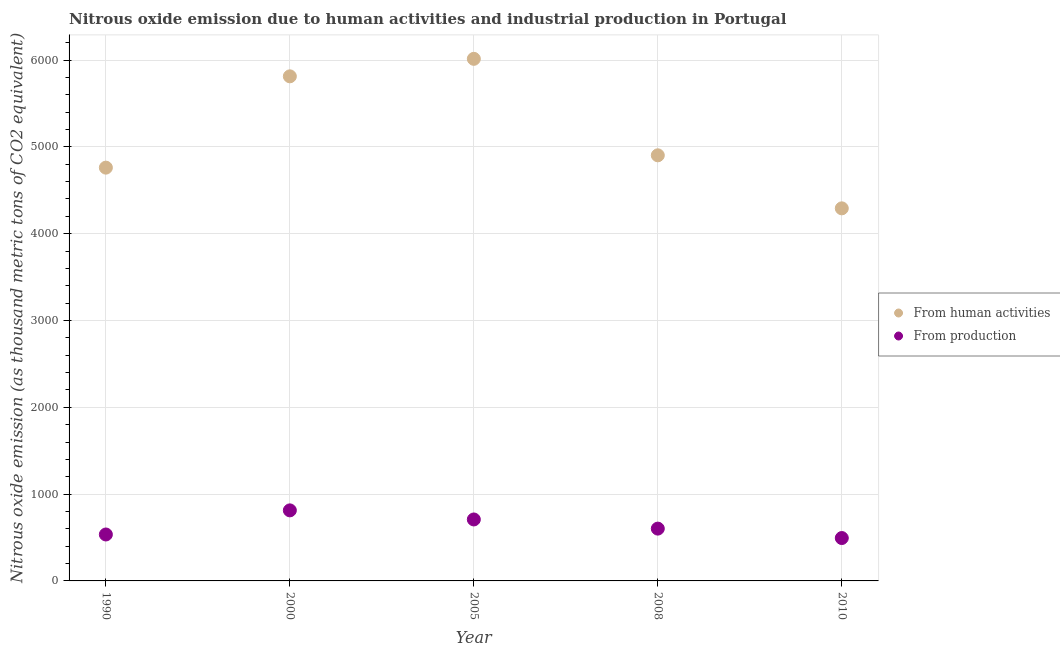How many different coloured dotlines are there?
Provide a succinct answer. 2. Is the number of dotlines equal to the number of legend labels?
Offer a terse response. Yes. What is the amount of emissions from human activities in 2008?
Offer a terse response. 4902.8. Across all years, what is the maximum amount of emissions generated from industries?
Your answer should be very brief. 812.7. Across all years, what is the minimum amount of emissions from human activities?
Offer a terse response. 4291.9. In which year was the amount of emissions from human activities minimum?
Keep it short and to the point. 2010. What is the total amount of emissions from human activities in the graph?
Your answer should be very brief. 2.58e+04. What is the difference between the amount of emissions generated from industries in 2000 and that in 2010?
Keep it short and to the point. 318.7. What is the difference between the amount of emissions from human activities in 2010 and the amount of emissions generated from industries in 2008?
Offer a terse response. 3689.4. What is the average amount of emissions from human activities per year?
Make the answer very short. 5156.46. In the year 2005, what is the difference between the amount of emissions from human activities and amount of emissions generated from industries?
Your answer should be compact. 5306.2. In how many years, is the amount of emissions from human activities greater than 5400 thousand metric tons?
Your answer should be very brief. 2. What is the ratio of the amount of emissions generated from industries in 1990 to that in 2005?
Provide a short and direct response. 0.76. Is the amount of emissions from human activities in 2005 less than that in 2010?
Provide a short and direct response. No. What is the difference between the highest and the second highest amount of emissions generated from industries?
Offer a very short reply. 104.7. What is the difference between the highest and the lowest amount of emissions generated from industries?
Keep it short and to the point. 318.7. Does the amount of emissions from human activities monotonically increase over the years?
Give a very brief answer. No. What is the difference between two consecutive major ticks on the Y-axis?
Your answer should be very brief. 1000. Are the values on the major ticks of Y-axis written in scientific E-notation?
Keep it short and to the point. No. Does the graph contain grids?
Your response must be concise. Yes. How many legend labels are there?
Ensure brevity in your answer.  2. What is the title of the graph?
Provide a short and direct response. Nitrous oxide emission due to human activities and industrial production in Portugal. Does "Rural Population" appear as one of the legend labels in the graph?
Your answer should be compact. No. What is the label or title of the Y-axis?
Offer a terse response. Nitrous oxide emission (as thousand metric tons of CO2 equivalent). What is the Nitrous oxide emission (as thousand metric tons of CO2 equivalent) in From human activities in 1990?
Keep it short and to the point. 4760.8. What is the Nitrous oxide emission (as thousand metric tons of CO2 equivalent) of From production in 1990?
Ensure brevity in your answer.  534.9. What is the Nitrous oxide emission (as thousand metric tons of CO2 equivalent) in From human activities in 2000?
Make the answer very short. 5812.6. What is the Nitrous oxide emission (as thousand metric tons of CO2 equivalent) of From production in 2000?
Give a very brief answer. 812.7. What is the Nitrous oxide emission (as thousand metric tons of CO2 equivalent) of From human activities in 2005?
Your response must be concise. 6014.2. What is the Nitrous oxide emission (as thousand metric tons of CO2 equivalent) of From production in 2005?
Your response must be concise. 708. What is the Nitrous oxide emission (as thousand metric tons of CO2 equivalent) in From human activities in 2008?
Your response must be concise. 4902.8. What is the Nitrous oxide emission (as thousand metric tons of CO2 equivalent) of From production in 2008?
Provide a succinct answer. 602.5. What is the Nitrous oxide emission (as thousand metric tons of CO2 equivalent) in From human activities in 2010?
Ensure brevity in your answer.  4291.9. What is the Nitrous oxide emission (as thousand metric tons of CO2 equivalent) of From production in 2010?
Offer a terse response. 494. Across all years, what is the maximum Nitrous oxide emission (as thousand metric tons of CO2 equivalent) of From human activities?
Your response must be concise. 6014.2. Across all years, what is the maximum Nitrous oxide emission (as thousand metric tons of CO2 equivalent) in From production?
Offer a very short reply. 812.7. Across all years, what is the minimum Nitrous oxide emission (as thousand metric tons of CO2 equivalent) in From human activities?
Provide a short and direct response. 4291.9. Across all years, what is the minimum Nitrous oxide emission (as thousand metric tons of CO2 equivalent) of From production?
Your answer should be compact. 494. What is the total Nitrous oxide emission (as thousand metric tons of CO2 equivalent) in From human activities in the graph?
Keep it short and to the point. 2.58e+04. What is the total Nitrous oxide emission (as thousand metric tons of CO2 equivalent) in From production in the graph?
Make the answer very short. 3152.1. What is the difference between the Nitrous oxide emission (as thousand metric tons of CO2 equivalent) of From human activities in 1990 and that in 2000?
Your answer should be compact. -1051.8. What is the difference between the Nitrous oxide emission (as thousand metric tons of CO2 equivalent) of From production in 1990 and that in 2000?
Provide a short and direct response. -277.8. What is the difference between the Nitrous oxide emission (as thousand metric tons of CO2 equivalent) of From human activities in 1990 and that in 2005?
Your answer should be compact. -1253.4. What is the difference between the Nitrous oxide emission (as thousand metric tons of CO2 equivalent) of From production in 1990 and that in 2005?
Keep it short and to the point. -173.1. What is the difference between the Nitrous oxide emission (as thousand metric tons of CO2 equivalent) of From human activities in 1990 and that in 2008?
Make the answer very short. -142. What is the difference between the Nitrous oxide emission (as thousand metric tons of CO2 equivalent) in From production in 1990 and that in 2008?
Provide a short and direct response. -67.6. What is the difference between the Nitrous oxide emission (as thousand metric tons of CO2 equivalent) of From human activities in 1990 and that in 2010?
Provide a short and direct response. 468.9. What is the difference between the Nitrous oxide emission (as thousand metric tons of CO2 equivalent) of From production in 1990 and that in 2010?
Offer a terse response. 40.9. What is the difference between the Nitrous oxide emission (as thousand metric tons of CO2 equivalent) of From human activities in 2000 and that in 2005?
Give a very brief answer. -201.6. What is the difference between the Nitrous oxide emission (as thousand metric tons of CO2 equivalent) of From production in 2000 and that in 2005?
Make the answer very short. 104.7. What is the difference between the Nitrous oxide emission (as thousand metric tons of CO2 equivalent) in From human activities in 2000 and that in 2008?
Your answer should be compact. 909.8. What is the difference between the Nitrous oxide emission (as thousand metric tons of CO2 equivalent) in From production in 2000 and that in 2008?
Ensure brevity in your answer.  210.2. What is the difference between the Nitrous oxide emission (as thousand metric tons of CO2 equivalent) of From human activities in 2000 and that in 2010?
Offer a terse response. 1520.7. What is the difference between the Nitrous oxide emission (as thousand metric tons of CO2 equivalent) in From production in 2000 and that in 2010?
Offer a terse response. 318.7. What is the difference between the Nitrous oxide emission (as thousand metric tons of CO2 equivalent) in From human activities in 2005 and that in 2008?
Ensure brevity in your answer.  1111.4. What is the difference between the Nitrous oxide emission (as thousand metric tons of CO2 equivalent) in From production in 2005 and that in 2008?
Your response must be concise. 105.5. What is the difference between the Nitrous oxide emission (as thousand metric tons of CO2 equivalent) of From human activities in 2005 and that in 2010?
Offer a very short reply. 1722.3. What is the difference between the Nitrous oxide emission (as thousand metric tons of CO2 equivalent) in From production in 2005 and that in 2010?
Offer a very short reply. 214. What is the difference between the Nitrous oxide emission (as thousand metric tons of CO2 equivalent) of From human activities in 2008 and that in 2010?
Keep it short and to the point. 610.9. What is the difference between the Nitrous oxide emission (as thousand metric tons of CO2 equivalent) in From production in 2008 and that in 2010?
Give a very brief answer. 108.5. What is the difference between the Nitrous oxide emission (as thousand metric tons of CO2 equivalent) of From human activities in 1990 and the Nitrous oxide emission (as thousand metric tons of CO2 equivalent) of From production in 2000?
Offer a very short reply. 3948.1. What is the difference between the Nitrous oxide emission (as thousand metric tons of CO2 equivalent) in From human activities in 1990 and the Nitrous oxide emission (as thousand metric tons of CO2 equivalent) in From production in 2005?
Offer a terse response. 4052.8. What is the difference between the Nitrous oxide emission (as thousand metric tons of CO2 equivalent) of From human activities in 1990 and the Nitrous oxide emission (as thousand metric tons of CO2 equivalent) of From production in 2008?
Give a very brief answer. 4158.3. What is the difference between the Nitrous oxide emission (as thousand metric tons of CO2 equivalent) in From human activities in 1990 and the Nitrous oxide emission (as thousand metric tons of CO2 equivalent) in From production in 2010?
Offer a terse response. 4266.8. What is the difference between the Nitrous oxide emission (as thousand metric tons of CO2 equivalent) in From human activities in 2000 and the Nitrous oxide emission (as thousand metric tons of CO2 equivalent) in From production in 2005?
Make the answer very short. 5104.6. What is the difference between the Nitrous oxide emission (as thousand metric tons of CO2 equivalent) of From human activities in 2000 and the Nitrous oxide emission (as thousand metric tons of CO2 equivalent) of From production in 2008?
Offer a very short reply. 5210.1. What is the difference between the Nitrous oxide emission (as thousand metric tons of CO2 equivalent) of From human activities in 2000 and the Nitrous oxide emission (as thousand metric tons of CO2 equivalent) of From production in 2010?
Your response must be concise. 5318.6. What is the difference between the Nitrous oxide emission (as thousand metric tons of CO2 equivalent) of From human activities in 2005 and the Nitrous oxide emission (as thousand metric tons of CO2 equivalent) of From production in 2008?
Keep it short and to the point. 5411.7. What is the difference between the Nitrous oxide emission (as thousand metric tons of CO2 equivalent) of From human activities in 2005 and the Nitrous oxide emission (as thousand metric tons of CO2 equivalent) of From production in 2010?
Keep it short and to the point. 5520.2. What is the difference between the Nitrous oxide emission (as thousand metric tons of CO2 equivalent) in From human activities in 2008 and the Nitrous oxide emission (as thousand metric tons of CO2 equivalent) in From production in 2010?
Your answer should be very brief. 4408.8. What is the average Nitrous oxide emission (as thousand metric tons of CO2 equivalent) of From human activities per year?
Offer a very short reply. 5156.46. What is the average Nitrous oxide emission (as thousand metric tons of CO2 equivalent) of From production per year?
Offer a very short reply. 630.42. In the year 1990, what is the difference between the Nitrous oxide emission (as thousand metric tons of CO2 equivalent) of From human activities and Nitrous oxide emission (as thousand metric tons of CO2 equivalent) of From production?
Make the answer very short. 4225.9. In the year 2000, what is the difference between the Nitrous oxide emission (as thousand metric tons of CO2 equivalent) in From human activities and Nitrous oxide emission (as thousand metric tons of CO2 equivalent) in From production?
Keep it short and to the point. 4999.9. In the year 2005, what is the difference between the Nitrous oxide emission (as thousand metric tons of CO2 equivalent) in From human activities and Nitrous oxide emission (as thousand metric tons of CO2 equivalent) in From production?
Keep it short and to the point. 5306.2. In the year 2008, what is the difference between the Nitrous oxide emission (as thousand metric tons of CO2 equivalent) of From human activities and Nitrous oxide emission (as thousand metric tons of CO2 equivalent) of From production?
Your answer should be very brief. 4300.3. In the year 2010, what is the difference between the Nitrous oxide emission (as thousand metric tons of CO2 equivalent) in From human activities and Nitrous oxide emission (as thousand metric tons of CO2 equivalent) in From production?
Provide a succinct answer. 3797.9. What is the ratio of the Nitrous oxide emission (as thousand metric tons of CO2 equivalent) of From human activities in 1990 to that in 2000?
Give a very brief answer. 0.82. What is the ratio of the Nitrous oxide emission (as thousand metric tons of CO2 equivalent) of From production in 1990 to that in 2000?
Give a very brief answer. 0.66. What is the ratio of the Nitrous oxide emission (as thousand metric tons of CO2 equivalent) of From human activities in 1990 to that in 2005?
Provide a succinct answer. 0.79. What is the ratio of the Nitrous oxide emission (as thousand metric tons of CO2 equivalent) in From production in 1990 to that in 2005?
Ensure brevity in your answer.  0.76. What is the ratio of the Nitrous oxide emission (as thousand metric tons of CO2 equivalent) of From production in 1990 to that in 2008?
Give a very brief answer. 0.89. What is the ratio of the Nitrous oxide emission (as thousand metric tons of CO2 equivalent) of From human activities in 1990 to that in 2010?
Make the answer very short. 1.11. What is the ratio of the Nitrous oxide emission (as thousand metric tons of CO2 equivalent) of From production in 1990 to that in 2010?
Offer a terse response. 1.08. What is the ratio of the Nitrous oxide emission (as thousand metric tons of CO2 equivalent) of From human activities in 2000 to that in 2005?
Give a very brief answer. 0.97. What is the ratio of the Nitrous oxide emission (as thousand metric tons of CO2 equivalent) in From production in 2000 to that in 2005?
Keep it short and to the point. 1.15. What is the ratio of the Nitrous oxide emission (as thousand metric tons of CO2 equivalent) in From human activities in 2000 to that in 2008?
Make the answer very short. 1.19. What is the ratio of the Nitrous oxide emission (as thousand metric tons of CO2 equivalent) of From production in 2000 to that in 2008?
Provide a short and direct response. 1.35. What is the ratio of the Nitrous oxide emission (as thousand metric tons of CO2 equivalent) of From human activities in 2000 to that in 2010?
Ensure brevity in your answer.  1.35. What is the ratio of the Nitrous oxide emission (as thousand metric tons of CO2 equivalent) of From production in 2000 to that in 2010?
Provide a succinct answer. 1.65. What is the ratio of the Nitrous oxide emission (as thousand metric tons of CO2 equivalent) in From human activities in 2005 to that in 2008?
Keep it short and to the point. 1.23. What is the ratio of the Nitrous oxide emission (as thousand metric tons of CO2 equivalent) in From production in 2005 to that in 2008?
Your answer should be very brief. 1.18. What is the ratio of the Nitrous oxide emission (as thousand metric tons of CO2 equivalent) in From human activities in 2005 to that in 2010?
Ensure brevity in your answer.  1.4. What is the ratio of the Nitrous oxide emission (as thousand metric tons of CO2 equivalent) in From production in 2005 to that in 2010?
Provide a succinct answer. 1.43. What is the ratio of the Nitrous oxide emission (as thousand metric tons of CO2 equivalent) in From human activities in 2008 to that in 2010?
Offer a terse response. 1.14. What is the ratio of the Nitrous oxide emission (as thousand metric tons of CO2 equivalent) of From production in 2008 to that in 2010?
Provide a short and direct response. 1.22. What is the difference between the highest and the second highest Nitrous oxide emission (as thousand metric tons of CO2 equivalent) in From human activities?
Your response must be concise. 201.6. What is the difference between the highest and the second highest Nitrous oxide emission (as thousand metric tons of CO2 equivalent) in From production?
Offer a very short reply. 104.7. What is the difference between the highest and the lowest Nitrous oxide emission (as thousand metric tons of CO2 equivalent) in From human activities?
Your answer should be compact. 1722.3. What is the difference between the highest and the lowest Nitrous oxide emission (as thousand metric tons of CO2 equivalent) of From production?
Make the answer very short. 318.7. 